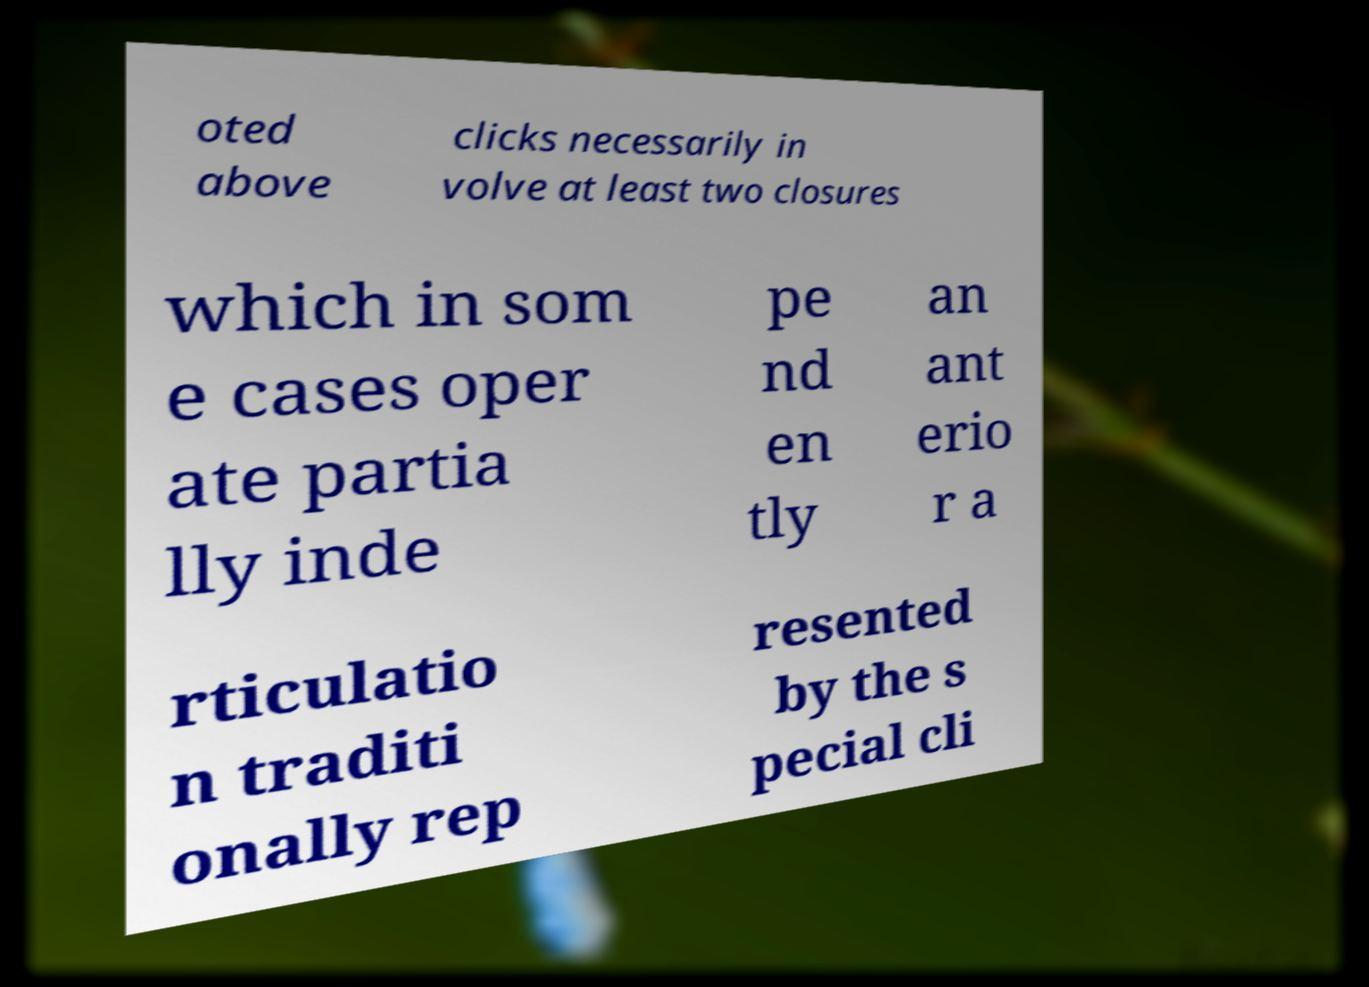Please identify and transcribe the text found in this image. oted above clicks necessarily in volve at least two closures which in som e cases oper ate partia lly inde pe nd en tly an ant erio r a rticulatio n traditi onally rep resented by the s pecial cli 